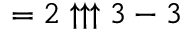Convert formula to latex. <formula><loc_0><loc_0><loc_500><loc_500>= 2 \uparrow \uparrow \uparrow 3 - 3</formula> 